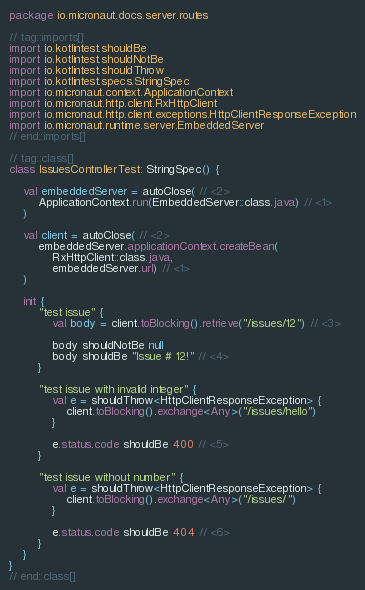<code> <loc_0><loc_0><loc_500><loc_500><_Kotlin_>package io.micronaut.docs.server.routes

// tag::imports[]
import io.kotlintest.shouldBe
import io.kotlintest.shouldNotBe
import io.kotlintest.shouldThrow
import io.kotlintest.specs.StringSpec
import io.micronaut.context.ApplicationContext
import io.micronaut.http.client.RxHttpClient
import io.micronaut.http.client.exceptions.HttpClientResponseException
import io.micronaut.runtime.server.EmbeddedServer
// end::imports[]

// tag::class[]
class IssuesControllerTest: StringSpec() {

    val embeddedServer = autoClose( // <2>
        ApplicationContext.run(EmbeddedServer::class.java) // <1>
    )

    val client = autoClose( // <2>
        embeddedServer.applicationContext.createBean(
            RxHttpClient::class.java,
            embeddedServer.url) // <1>
    )

    init {
        "test issue" {
            val body = client.toBlocking().retrieve("/issues/12") // <3>

            body shouldNotBe null
            body shouldBe "Issue # 12!" // <4>
        }

        "test issue with invalid integer" {
            val e = shouldThrow<HttpClientResponseException> {
                client.toBlocking().exchange<Any>("/issues/hello")
            }

            e.status.code shouldBe 400 // <5>
        }

        "test issue without number" {
            val e = shouldThrow<HttpClientResponseException> {
                client.toBlocking().exchange<Any>("/issues/")
            }

            e.status.code shouldBe 404 // <6>
        }
    }
}
// end::class[]
</code> 